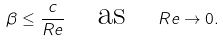<formula> <loc_0><loc_0><loc_500><loc_500>\beta \leq \frac { c } { R e } \quad \text {as} \quad R e \rightarrow 0 .</formula> 